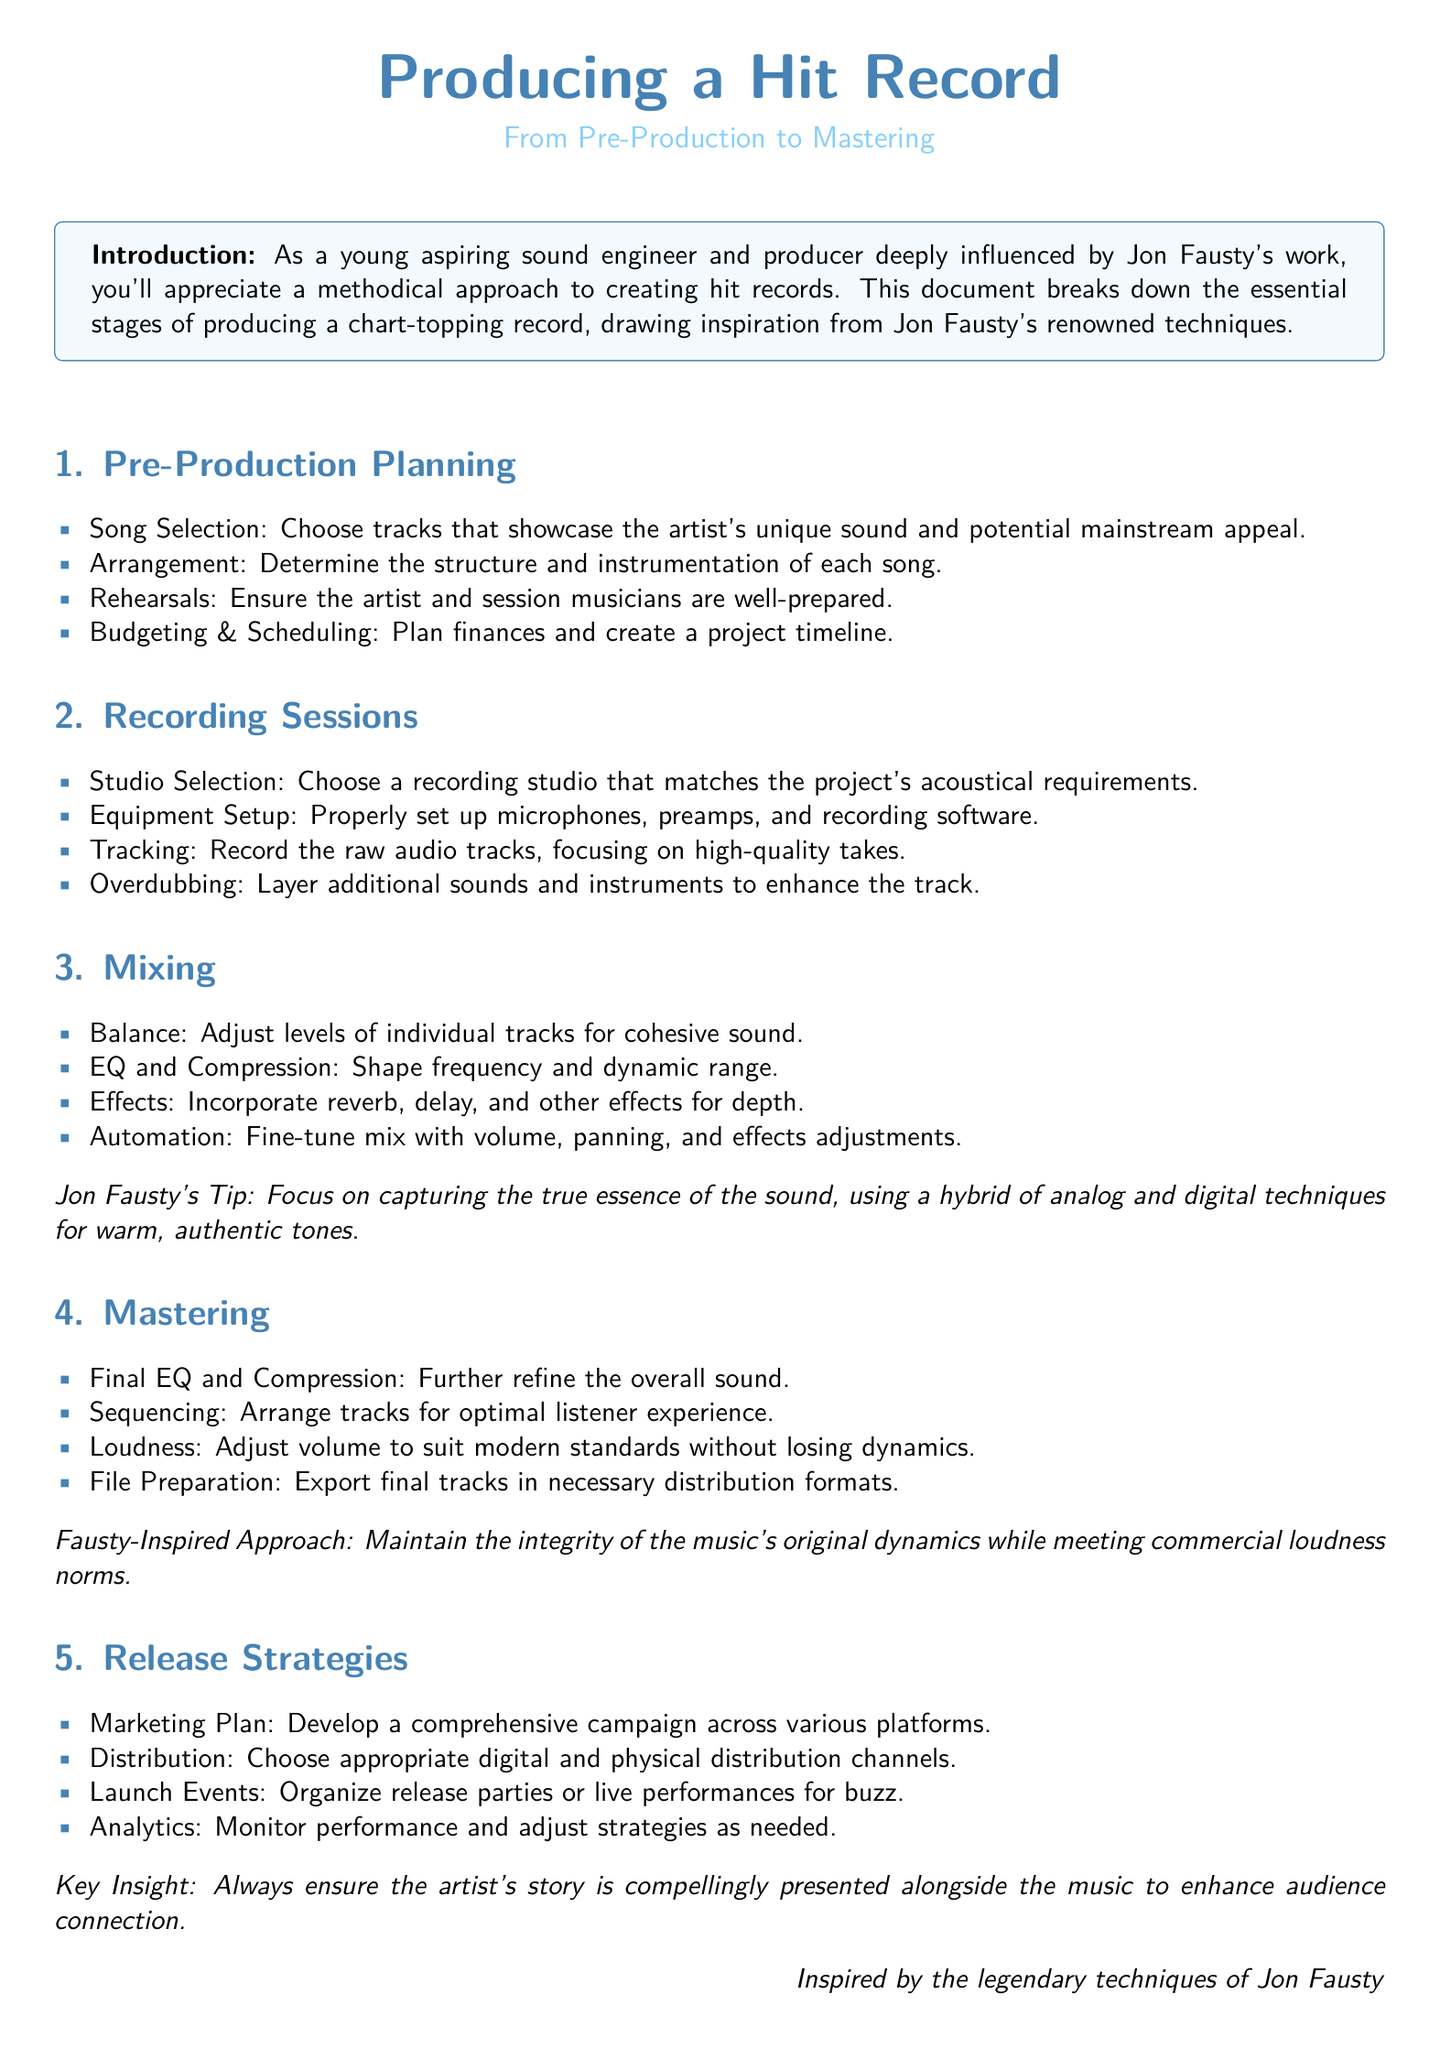What are the stages of producing a hit record? The document lists five stages: Pre-Production Planning, Recording Sessions, Mixing, Mastering, and Release Strategies.
Answer: Five stages What is the focus during the Mixing stage? The Mixing stage involves adjusting levels, shaping frequency, incorporating effects, and fine-tuning the mix.
Answer: Adjusting levels What does Jon Fausty advise for capturing sound? Jon Fausty advises using a hybrid of analog and digital techniques for warm, authentic tones.
Answer: Hybrid of analog and digital techniques What is a key insight provided for Release Strategies? The document states that the artist's story should be compellingly presented alongside the music to enhance audience connection.
Answer: Compellingly presented story What is the objective of the Pre-Production Planning phase? The objective is to prepare song selections, arrangements, rehearsals, and budgeting for the recording process.
Answer: Prepare song selections and arrangements How should the final tracks be prepared in the Mastering stage? The final tracks should be exported in necessary distribution formats.
Answer: Necessary distribution formats What is the advised method for ensuring artist preparation? The document emphasizes the importance of rehearsals to ensure the artist and session musicians are well-prepared.
Answer: Rehearsals What is suggested as part of the Marketing Plan in Release Strategies? Developing a comprehensive campaign across various platforms is suggested.
Answer: Comprehensive campaign How does the document suggest adjusting volume during Mastering? It suggests adjusting loudness to suit modern standards without losing dynamics.
Answer: Modern standards without losing dynamics 